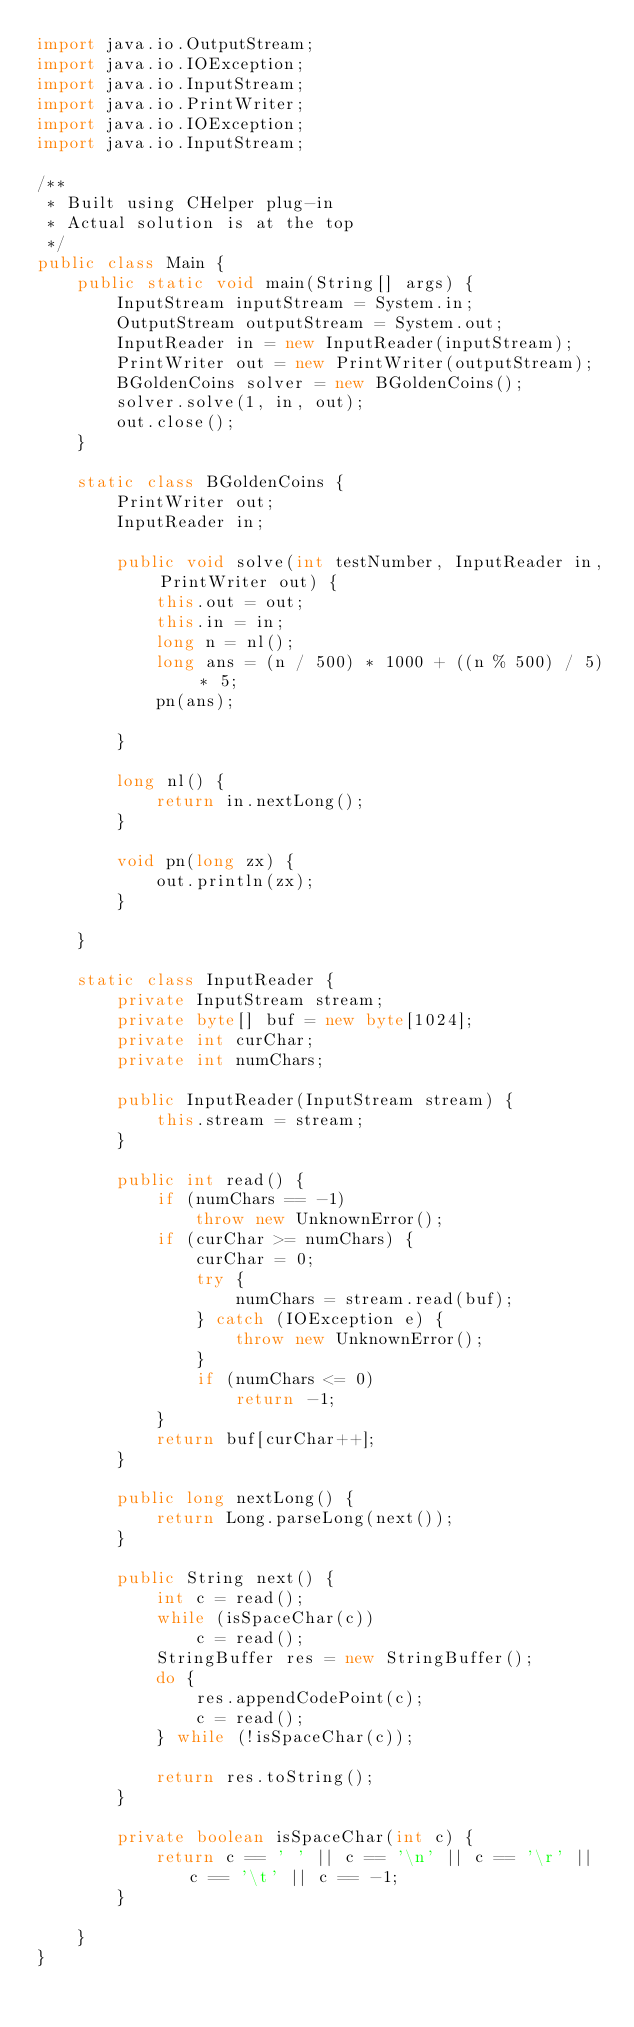<code> <loc_0><loc_0><loc_500><loc_500><_Java_>import java.io.OutputStream;
import java.io.IOException;
import java.io.InputStream;
import java.io.PrintWriter;
import java.io.IOException;
import java.io.InputStream;

/**
 * Built using CHelper plug-in
 * Actual solution is at the top
 */
public class Main {
    public static void main(String[] args) {
        InputStream inputStream = System.in;
        OutputStream outputStream = System.out;
        InputReader in = new InputReader(inputStream);
        PrintWriter out = new PrintWriter(outputStream);
        BGoldenCoins solver = new BGoldenCoins();
        solver.solve(1, in, out);
        out.close();
    }

    static class BGoldenCoins {
        PrintWriter out;
        InputReader in;

        public void solve(int testNumber, InputReader in, PrintWriter out) {
            this.out = out;
            this.in = in;
            long n = nl();
            long ans = (n / 500) * 1000 + ((n % 500) / 5) * 5;
            pn(ans);

        }

        long nl() {
            return in.nextLong();
        }

        void pn(long zx) {
            out.println(zx);
        }

    }

    static class InputReader {
        private InputStream stream;
        private byte[] buf = new byte[1024];
        private int curChar;
        private int numChars;

        public InputReader(InputStream stream) {
            this.stream = stream;
        }

        public int read() {
            if (numChars == -1)
                throw new UnknownError();
            if (curChar >= numChars) {
                curChar = 0;
                try {
                    numChars = stream.read(buf);
                } catch (IOException e) {
                    throw new UnknownError();
                }
                if (numChars <= 0)
                    return -1;
            }
            return buf[curChar++];
        }

        public long nextLong() {
            return Long.parseLong(next());
        }

        public String next() {
            int c = read();
            while (isSpaceChar(c))
                c = read();
            StringBuffer res = new StringBuffer();
            do {
                res.appendCodePoint(c);
                c = read();
            } while (!isSpaceChar(c));

            return res.toString();
        }

        private boolean isSpaceChar(int c) {
            return c == ' ' || c == '\n' || c == '\r' || c == '\t' || c == -1;
        }

    }
}

</code> 